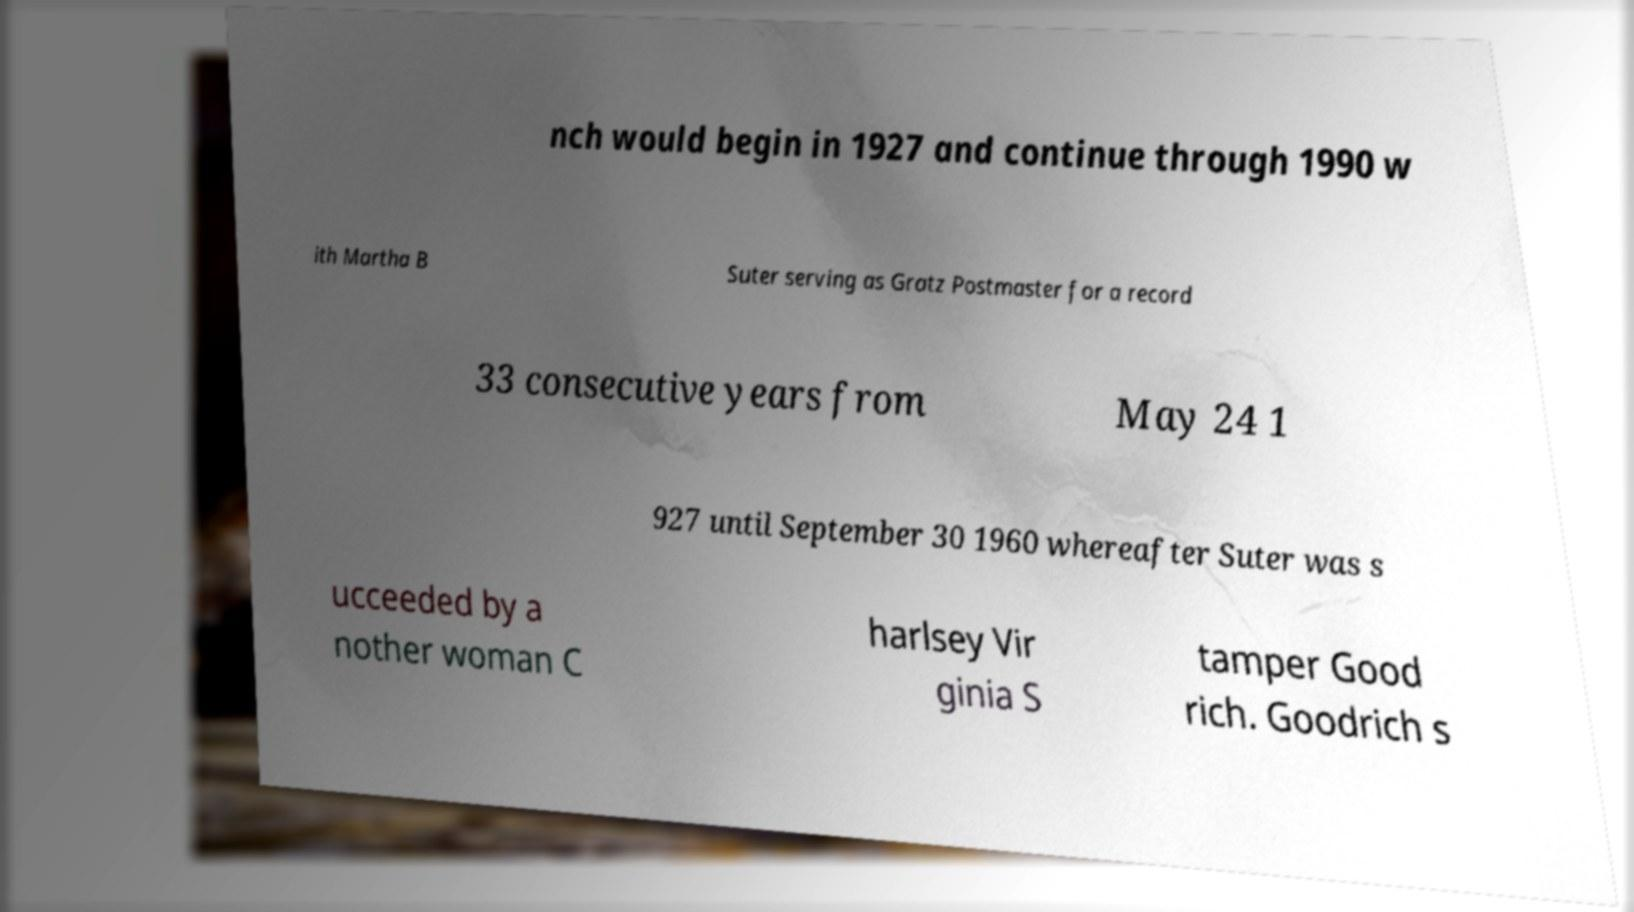What messages or text are displayed in this image? I need them in a readable, typed format. nch would begin in 1927 and continue through 1990 w ith Martha B Suter serving as Gratz Postmaster for a record 33 consecutive years from May 24 1 927 until September 30 1960 whereafter Suter was s ucceeded by a nother woman C harlsey Vir ginia S tamper Good rich. Goodrich s 